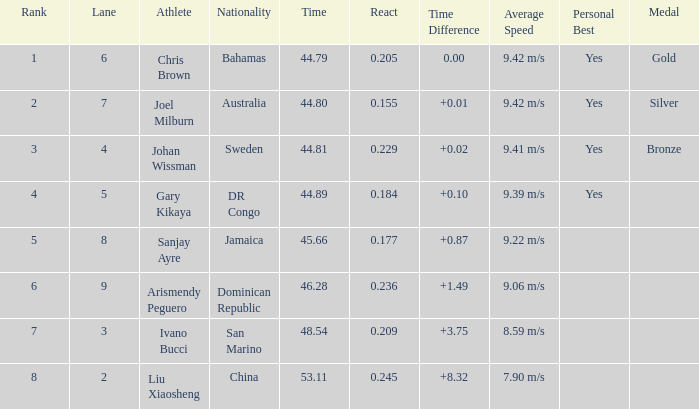245? 0.0. 